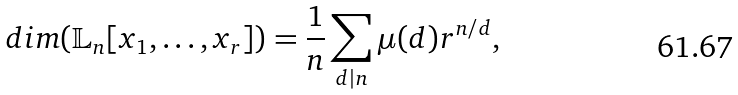<formula> <loc_0><loc_0><loc_500><loc_500>d i m ( \mathbb { L } _ { n } [ x _ { 1 } , \dots , x _ { r } ] ) = \frac { 1 } { n } \sum _ { d | n } \mu ( d ) r ^ { n / d } ,</formula> 